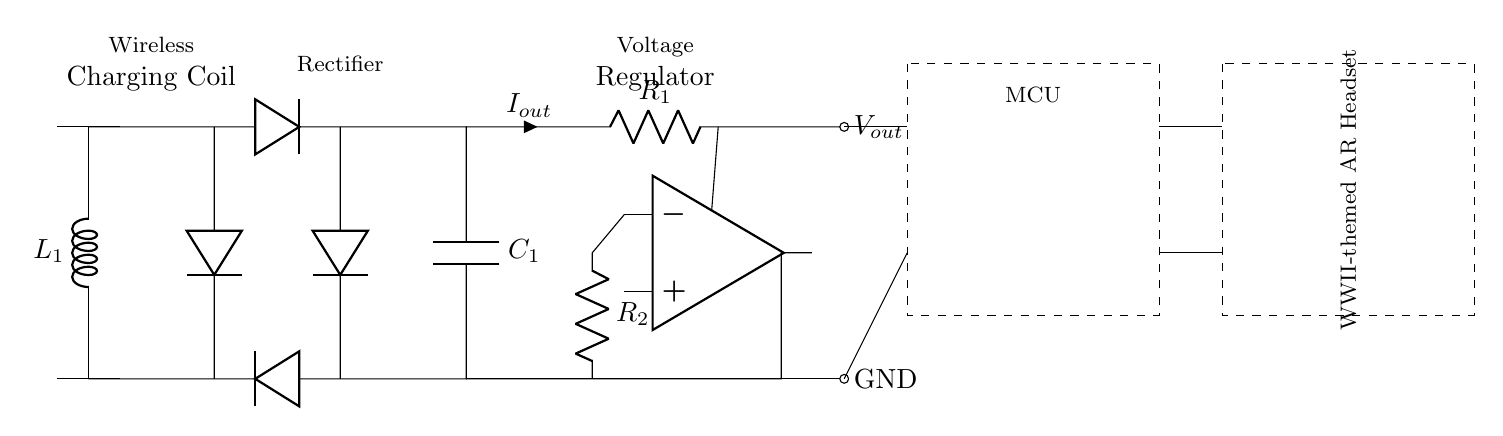What type of coil is used in this circuit? The circuit includes a wireless charging coil labeled L1, which is important for inductive power transfer.
Answer: Wireless charging coil How many diodes are present in the circuit? Counting the diodes in the rectifier section reveals that there are four diodes connected in total, as shown in the diagram.
Answer: Four What is the function of the voltage regulator in this circuit? The voltage regulator, depicted as an operational amplifier connected to resistors, ensures that the output voltage remains stable for the connected devices.
Answer: Voltage regulation What component charges the capacitor in this circuit? The diodes in the rectifier section allow current to flow from the wireless charging coil to the capacitor, charging it up during operation.
Answer: Diodes What does MCU stand for in this diagram? The dashed rectangle labeled 'MCU' refers to the microcontroller unit, which manages tasks and controls operations in the AR headset system.
Answer: Microcontroller unit What is the output of the voltage regulator labeled as? The output of the voltage regulator is labeled as Vout, which supplies the necessary voltage to power the connected AR headset.
Answer: Vout How is the AR headset connected to the circuit? The AR headset is connected to the output of the voltage regulator and the ground, indicating that it receives power and has a return path.
Answer: Output and ground 